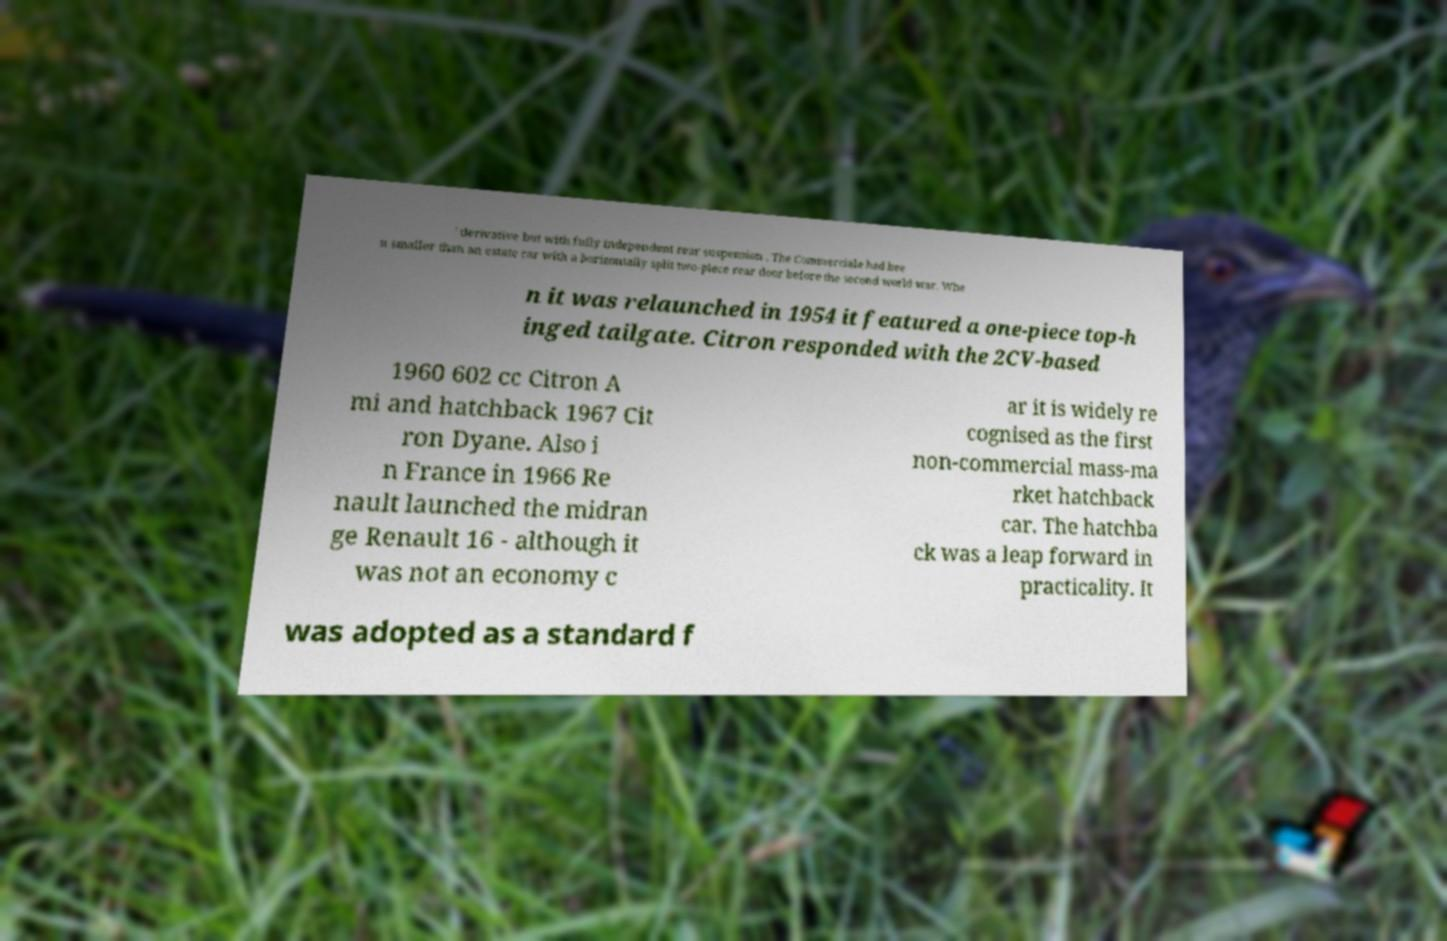Please read and relay the text visible in this image. What does it say? ' derivative but with fully independent rear suspension . The Commerciale had bee n smaller than an estate car with a horizontally split two-piece rear door before the second world war. Whe n it was relaunched in 1954 it featured a one-piece top-h inged tailgate. Citron responded with the 2CV-based 1960 602 cc Citron A mi and hatchback 1967 Cit ron Dyane. Also i n France in 1966 Re nault launched the midran ge Renault 16 - although it was not an economy c ar it is widely re cognised as the first non-commercial mass-ma rket hatchback car. The hatchba ck was a leap forward in practicality. It was adopted as a standard f 